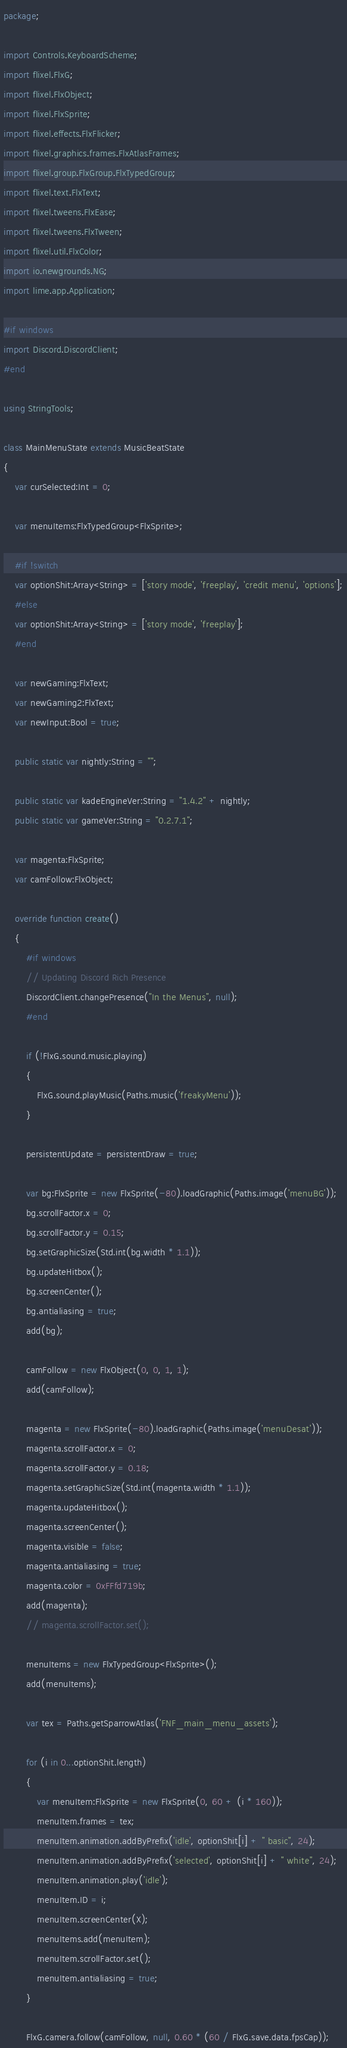Convert code to text. <code><loc_0><loc_0><loc_500><loc_500><_Haxe_>package;

import Controls.KeyboardScheme;
import flixel.FlxG;
import flixel.FlxObject;
import flixel.FlxSprite;
import flixel.effects.FlxFlicker;
import flixel.graphics.frames.FlxAtlasFrames;
import flixel.group.FlxGroup.FlxTypedGroup;
import flixel.text.FlxText;
import flixel.tweens.FlxEase;
import flixel.tweens.FlxTween;
import flixel.util.FlxColor;
import io.newgrounds.NG;
import lime.app.Application;

#if windows
import Discord.DiscordClient;
#end

using StringTools;

class MainMenuState extends MusicBeatState
{
	var curSelected:Int = 0;

	var menuItems:FlxTypedGroup<FlxSprite>;

	#if !switch
	var optionShit:Array<String> = ['story mode', 'freeplay', 'credit menu', 'options'];
	#else
	var optionShit:Array<String> = ['story mode', 'freeplay'];
	#end

	var newGaming:FlxText;
	var newGaming2:FlxText;
	var newInput:Bool = true;

	public static var nightly:String = "";

	public static var kadeEngineVer:String = "1.4.2" + nightly;
	public static var gameVer:String = "0.2.7.1";

	var magenta:FlxSprite;
	var camFollow:FlxObject;

	override function create()
	{
		#if windows
		// Updating Discord Rich Presence
		DiscordClient.changePresence("In the Menus", null);
		#end

		if (!FlxG.sound.music.playing)
		{
			FlxG.sound.playMusic(Paths.music('freakyMenu'));
		}

		persistentUpdate = persistentDraw = true;

		var bg:FlxSprite = new FlxSprite(-80).loadGraphic(Paths.image('menuBG'));
		bg.scrollFactor.x = 0;
		bg.scrollFactor.y = 0.15;
		bg.setGraphicSize(Std.int(bg.width * 1.1));
		bg.updateHitbox();
		bg.screenCenter();
		bg.antialiasing = true;
		add(bg);

		camFollow = new FlxObject(0, 0, 1, 1);
		add(camFollow);

		magenta = new FlxSprite(-80).loadGraphic(Paths.image('menuDesat'));
		magenta.scrollFactor.x = 0;
		magenta.scrollFactor.y = 0.18;
		magenta.setGraphicSize(Std.int(magenta.width * 1.1));
		magenta.updateHitbox();
		magenta.screenCenter();
		magenta.visible = false;
		magenta.antialiasing = true;
		magenta.color = 0xFFfd719b;
		add(magenta);
		// magenta.scrollFactor.set();

		menuItems = new FlxTypedGroup<FlxSprite>();
		add(menuItems);

		var tex = Paths.getSparrowAtlas('FNF_main_menu_assets');

		for (i in 0...optionShit.length)
		{
			var menuItem:FlxSprite = new FlxSprite(0, 60 + (i * 160));
			menuItem.frames = tex;
			menuItem.animation.addByPrefix('idle', optionShit[i] + " basic", 24);
			menuItem.animation.addByPrefix('selected', optionShit[i] + " white", 24);
			menuItem.animation.play('idle');
			menuItem.ID = i;
			menuItem.screenCenter(X);
			menuItems.add(menuItem);
			menuItem.scrollFactor.set();
			menuItem.antialiasing = true;
		}

		FlxG.camera.follow(camFollow, null, 0.60 * (60 / FlxG.save.data.fpsCap));
</code> 